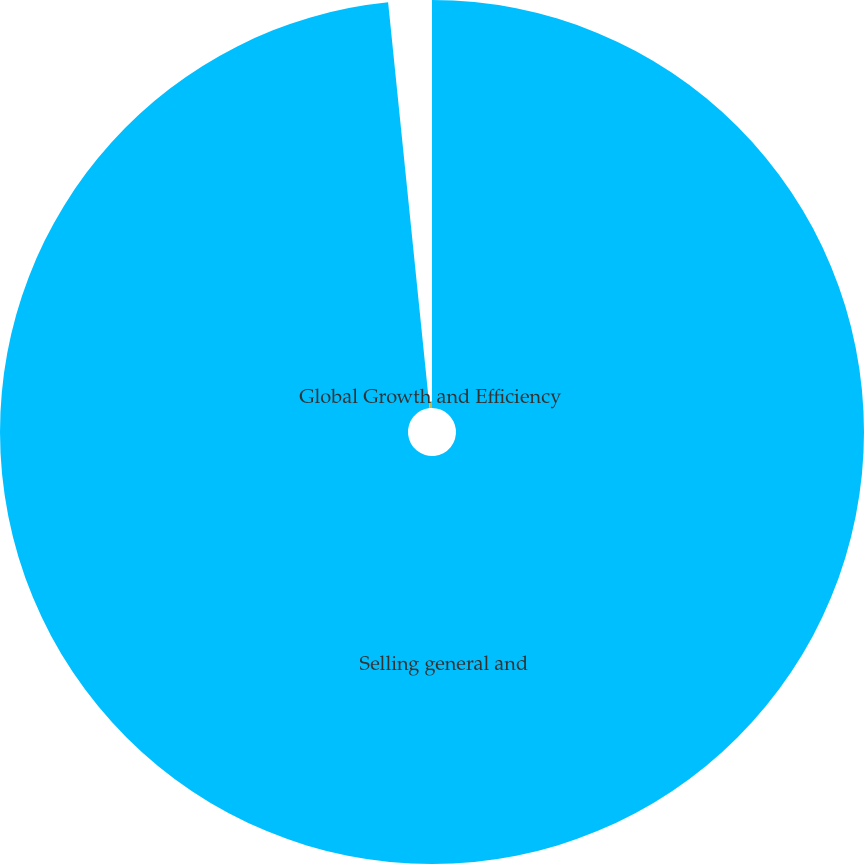Convert chart to OTSL. <chart><loc_0><loc_0><loc_500><loc_500><pie_chart><fcel>Selling general and<fcel>Global Growth and Efficiency<nl><fcel>98.38%<fcel>1.62%<nl></chart> 